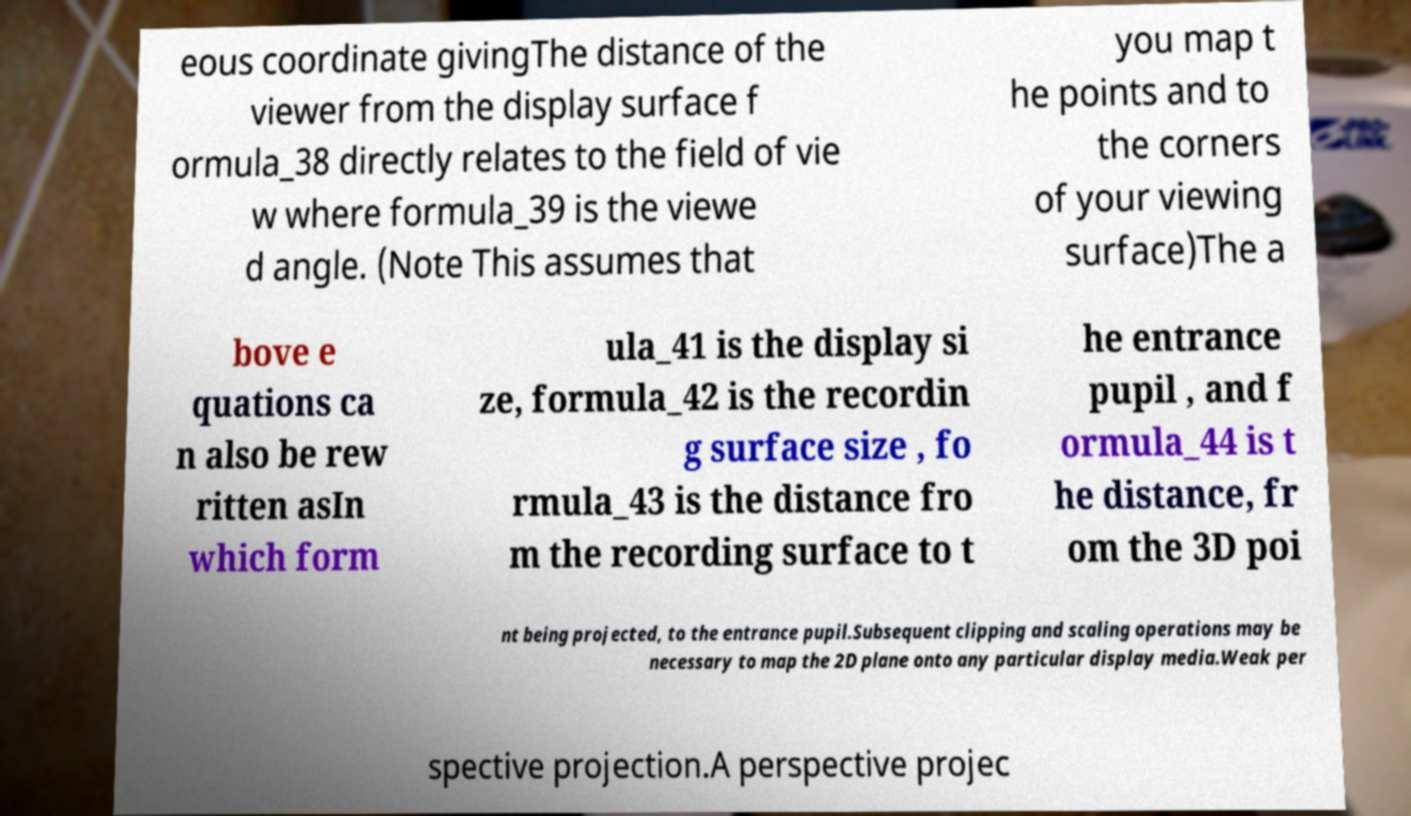Could you extract and type out the text from this image? eous coordinate givingThe distance of the viewer from the display surface f ormula_38 directly relates to the field of vie w where formula_39 is the viewe d angle. (Note This assumes that you map t he points and to the corners of your viewing surface)The a bove e quations ca n also be rew ritten asIn which form ula_41 is the display si ze, formula_42 is the recordin g surface size , fo rmula_43 is the distance fro m the recording surface to t he entrance pupil , and f ormula_44 is t he distance, fr om the 3D poi nt being projected, to the entrance pupil.Subsequent clipping and scaling operations may be necessary to map the 2D plane onto any particular display media.Weak per spective projection.A perspective projec 